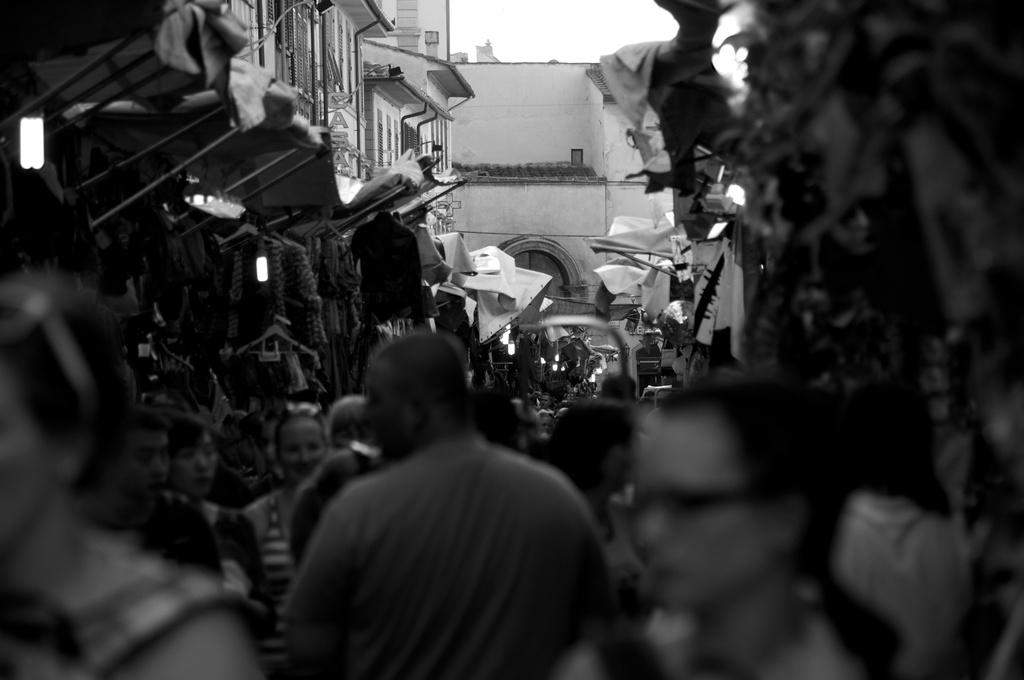What is the color scheme of the image? The image is black and white. Who or what can be seen in the image? There are people in the image. What type of structures are present in the image? There are sheds and buildings in the image. What else can be seen in the image besides structures? There are clothes visible in the image. Are there any artificial light sources in the image? Yes, there are lights in the image. What is located on the right side of the image? There are objects on the right side of the image. What can be seen in the background of the image? The sky is visible in the image. Can you tell me how many rays are coming from the lights in the image? There is no mention of rays in the image; it only states that there are lights present. What type of hose is being used by the people in the image? There is no hose visible in the image. 